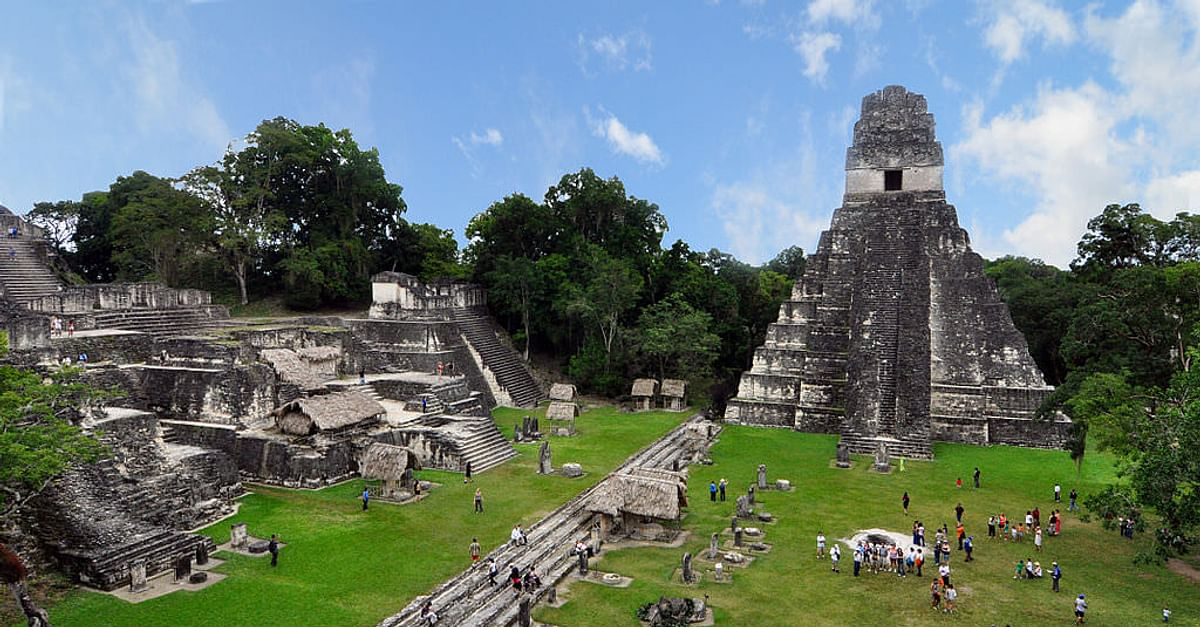Imagine this temple at the height of its use. What might it have looked like? At the height of its use, the Tikal temple complex would have been a bustling hub of activity. Crowds of people, including priests, nobility, and commoners, would gather for religious ceremonies, political events, and everyday trade. The towering temples, adorned with vibrant murals and intricate carvings, would stand out against the clear blue sky. The structures would be well-maintained, with fresh paint and decorations for various festivals. Markets would be filled with goods, including textiles, food, and pottery. The sounds of conversation, religious chanting, and the music of traditional Maya instruments would fill the air. The entire complex would be alive with the vibrant culture of the ancient Maya civilization. If these ruins were the setting for a fantasy novel, what kind of adventures might take place here? In a fantasy novel, the Tikal temple complex could be the heart of an ancient and mystical civilization. Brave adventurers might come to seek powerful relics hidden within the temple's depths, guarded by magical creatures and ancient spells. The dense jungle could be home to mythical beasts and enchanted flora. Secret chambers and passageways could hold the secrets of lost dynasties or lead to otherworldly realms. The temples might be alive with spirits of the past, offering guidance or posing challenges to those who dare to uncover their mysteries. Grand tournaments, royal intrigues, and epic battles could unfold against this majestic backdrop, with the fate of entire kingdoms hanging in the balance. 